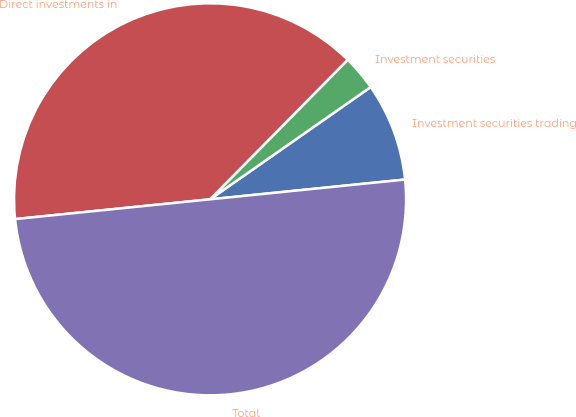<chart> <loc_0><loc_0><loc_500><loc_500><pie_chart><fcel>Investment securities trading<fcel>Investment securities<fcel>Direct investments in<fcel>Total<nl><fcel>8.1%<fcel>2.9%<fcel>39.0%<fcel>50.0%<nl></chart> 